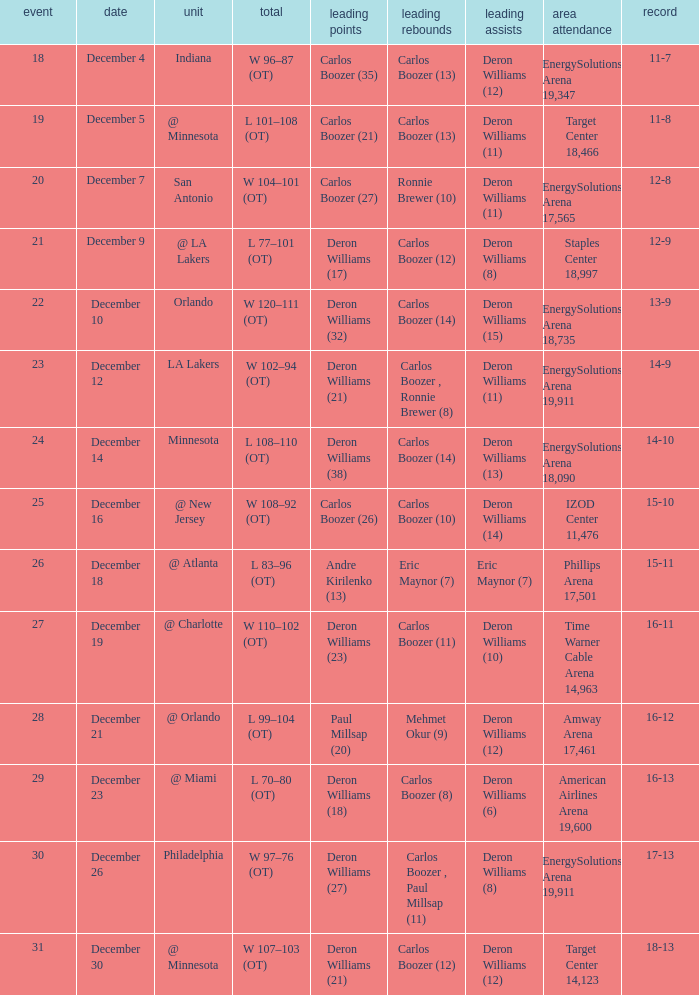When was the game in which Deron Williams (13) did the high assists played? December 14. 